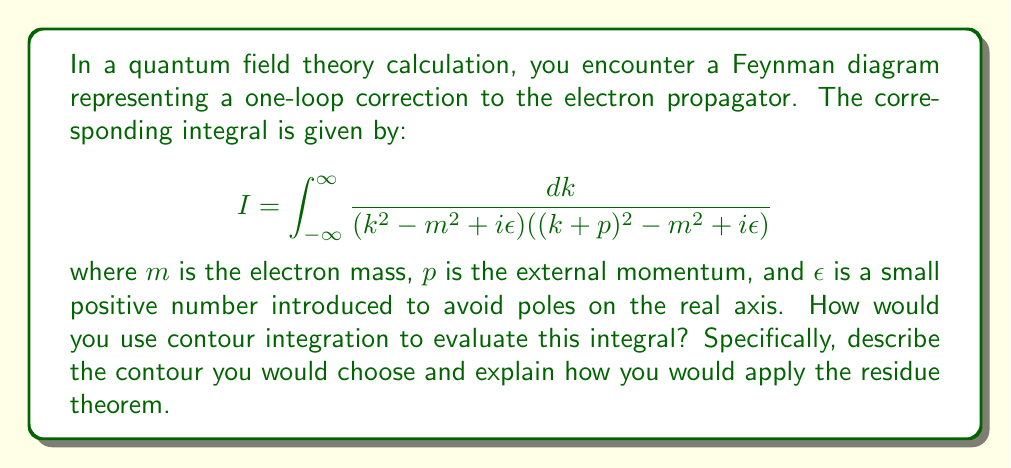Teach me how to tackle this problem. To evaluate this integral using contour integration, we can follow these steps:

1) First, we need to choose an appropriate contour. Given the form of the integrand, a semi-circular contour in the upper half-plane is suitable. This contour consists of a line along the real axis from $-R$ to $R$, and a semi-circle of radius $R$ in the upper half-plane.

2) The contour integral is:

   $$\oint_C \frac{dz}{(z^2 - m^2 + i\epsilon)((z+p)^2 - m^2 + i\epsilon)}$$

   where $C$ is our chosen contour.

3) As $R \to \infty$, the contribution from the semi-circular part of the contour vanishes due to Jordan's lemma.

4) The poles of the integrand are at:
   
   $$z_1 = \sqrt{m^2 - i\epsilon}$$
   $$z_2 = -\sqrt{m^2 - i\epsilon}$$
   $$z_3 = -p + \sqrt{m^2 - i\epsilon}$$
   $$z_4 = -p - \sqrt{m^2 - i\epsilon}$$

5) In the upper half-plane, only $z_1$ and $z_3$ contribute.

6) By the residue theorem:

   $$\oint_C f(z)dz = 2\pi i \sum \text{Res}(f, z_k)$$

   where the sum is over the poles in the upper half-plane.

7) The residues at $z_1$ and $z_3$ are:

   $$\text{Res}(f, z_1) = \frac{1}{2z_1((z_1+p)^2 - m^2 + i\epsilon)}$$
   $$\text{Res}(f, z_3) = \frac{1}{(z_3^2 - m^2 + i\epsilon)(2(z_3+p))}$$

8) The original integral $I$ is equal to the contour integral in the limit as $R \to \infty$. Therefore:

   $$I = 2\pi i [\text{Res}(f, z_1) + \text{Res}(f, z_3)]$$

This method allows us to transform a complicated real integral into a sum of residues, which is often easier to compute explicitly.
Answer: The integral can be evaluated as:

$$I = 2\pi i \left[\frac{1}{2\sqrt{m^2 - i\epsilon}((\sqrt{m^2 - i\epsilon}+p)^2 - m^2 + i\epsilon)} + \frac{1}{((-p+\sqrt{m^2 - i\epsilon})^2 - m^2 + i\epsilon)(2\sqrt{m^2 - i\epsilon})}\right]$$

This expression can be further simplified by taking the limit $\epsilon \to 0^+$. 